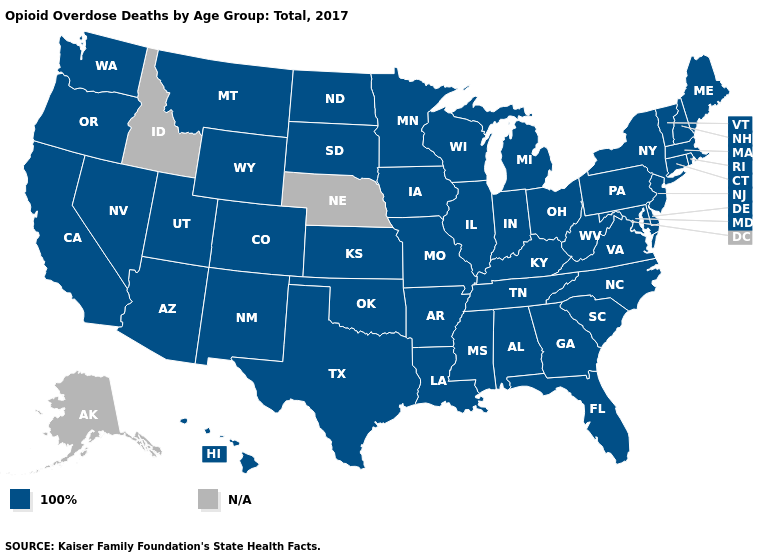Name the states that have a value in the range N/A?
Be succinct. Alaska, Idaho, Nebraska. What is the value of Arizona?
Keep it brief. 100%. Is the legend a continuous bar?
Write a very short answer. No. What is the value of Rhode Island?
Quick response, please. 100%. Name the states that have a value in the range N/A?
Keep it brief. Alaska, Idaho, Nebraska. What is the lowest value in the MidWest?
Be succinct. 100%. Among the states that border Connecticut , which have the lowest value?
Quick response, please. Massachusetts, New York, Rhode Island. What is the value of Massachusetts?
Short answer required. 100%. Name the states that have a value in the range N/A?
Keep it brief. Alaska, Idaho, Nebraska. How many symbols are there in the legend?
Keep it brief. 2. Which states have the highest value in the USA?
Keep it brief. Alabama, Arizona, Arkansas, California, Colorado, Connecticut, Delaware, Florida, Georgia, Hawaii, Illinois, Indiana, Iowa, Kansas, Kentucky, Louisiana, Maine, Maryland, Massachusetts, Michigan, Minnesota, Mississippi, Missouri, Montana, Nevada, New Hampshire, New Jersey, New Mexico, New York, North Carolina, North Dakota, Ohio, Oklahoma, Oregon, Pennsylvania, Rhode Island, South Carolina, South Dakota, Tennessee, Texas, Utah, Vermont, Virginia, Washington, West Virginia, Wisconsin, Wyoming. What is the lowest value in states that border Nebraska?
Give a very brief answer. 100%. How many symbols are there in the legend?
Answer briefly. 2. Does the first symbol in the legend represent the smallest category?
Quick response, please. Yes. 